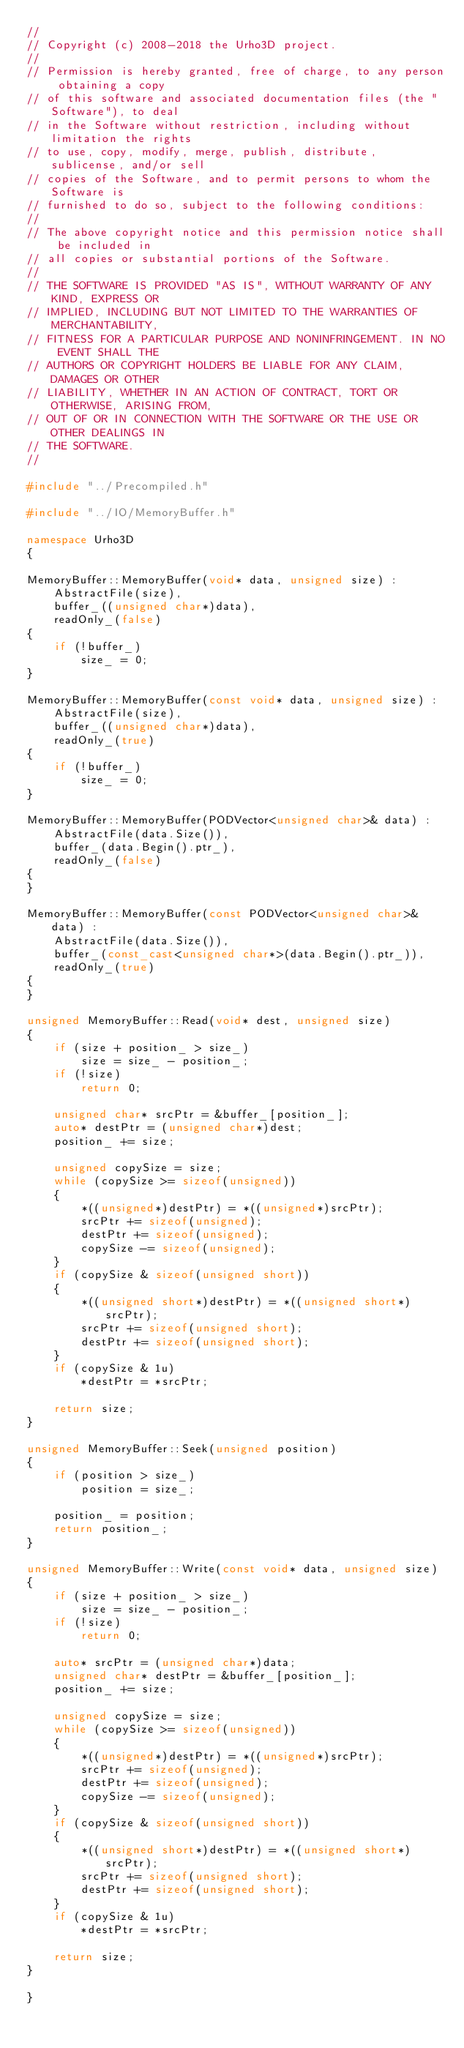<code> <loc_0><loc_0><loc_500><loc_500><_C++_>//
// Copyright (c) 2008-2018 the Urho3D project.
//
// Permission is hereby granted, free of charge, to any person obtaining a copy
// of this software and associated documentation files (the "Software"), to deal
// in the Software without restriction, including without limitation the rights
// to use, copy, modify, merge, publish, distribute, sublicense, and/or sell
// copies of the Software, and to permit persons to whom the Software is
// furnished to do so, subject to the following conditions:
//
// The above copyright notice and this permission notice shall be included in
// all copies or substantial portions of the Software.
//
// THE SOFTWARE IS PROVIDED "AS IS", WITHOUT WARRANTY OF ANY KIND, EXPRESS OR
// IMPLIED, INCLUDING BUT NOT LIMITED TO THE WARRANTIES OF MERCHANTABILITY,
// FITNESS FOR A PARTICULAR PURPOSE AND NONINFRINGEMENT. IN NO EVENT SHALL THE
// AUTHORS OR COPYRIGHT HOLDERS BE LIABLE FOR ANY CLAIM, DAMAGES OR OTHER
// LIABILITY, WHETHER IN AN ACTION OF CONTRACT, TORT OR OTHERWISE, ARISING FROM,
// OUT OF OR IN CONNECTION WITH THE SOFTWARE OR THE USE OR OTHER DEALINGS IN
// THE SOFTWARE.
//

#include "../Precompiled.h"

#include "../IO/MemoryBuffer.h"

namespace Urho3D
{

MemoryBuffer::MemoryBuffer(void* data, unsigned size) :
    AbstractFile(size),
    buffer_((unsigned char*)data),
    readOnly_(false)
{
    if (!buffer_)
        size_ = 0;
}

MemoryBuffer::MemoryBuffer(const void* data, unsigned size) :
    AbstractFile(size),
    buffer_((unsigned char*)data),
    readOnly_(true)
{
    if (!buffer_)
        size_ = 0;
}

MemoryBuffer::MemoryBuffer(PODVector<unsigned char>& data) :
    AbstractFile(data.Size()),
    buffer_(data.Begin().ptr_),
    readOnly_(false)
{
}

MemoryBuffer::MemoryBuffer(const PODVector<unsigned char>& data) :
    AbstractFile(data.Size()),
    buffer_(const_cast<unsigned char*>(data.Begin().ptr_)),
    readOnly_(true)
{
}

unsigned MemoryBuffer::Read(void* dest, unsigned size)
{
    if (size + position_ > size_)
        size = size_ - position_;
    if (!size)
        return 0;

    unsigned char* srcPtr = &buffer_[position_];
    auto* destPtr = (unsigned char*)dest;
    position_ += size;

    unsigned copySize = size;
    while (copySize >= sizeof(unsigned))
    {
        *((unsigned*)destPtr) = *((unsigned*)srcPtr);
        srcPtr += sizeof(unsigned);
        destPtr += sizeof(unsigned);
        copySize -= sizeof(unsigned);
    }
    if (copySize & sizeof(unsigned short))
    {
        *((unsigned short*)destPtr) = *((unsigned short*)srcPtr);
        srcPtr += sizeof(unsigned short);
        destPtr += sizeof(unsigned short);
    }
    if (copySize & 1u)
        *destPtr = *srcPtr;

    return size;
}

unsigned MemoryBuffer::Seek(unsigned position)
{
    if (position > size_)
        position = size_;

    position_ = position;
    return position_;
}

unsigned MemoryBuffer::Write(const void* data, unsigned size)
{
    if (size + position_ > size_)
        size = size_ - position_;
    if (!size)
        return 0;

    auto* srcPtr = (unsigned char*)data;
    unsigned char* destPtr = &buffer_[position_];
    position_ += size;

    unsigned copySize = size;
    while (copySize >= sizeof(unsigned))
    {
        *((unsigned*)destPtr) = *((unsigned*)srcPtr);
        srcPtr += sizeof(unsigned);
        destPtr += sizeof(unsigned);
        copySize -= sizeof(unsigned);
    }
    if (copySize & sizeof(unsigned short))
    {
        *((unsigned short*)destPtr) = *((unsigned short*)srcPtr);
        srcPtr += sizeof(unsigned short);
        destPtr += sizeof(unsigned short);
    }
    if (copySize & 1u)
        *destPtr = *srcPtr;

    return size;
}

}
</code> 